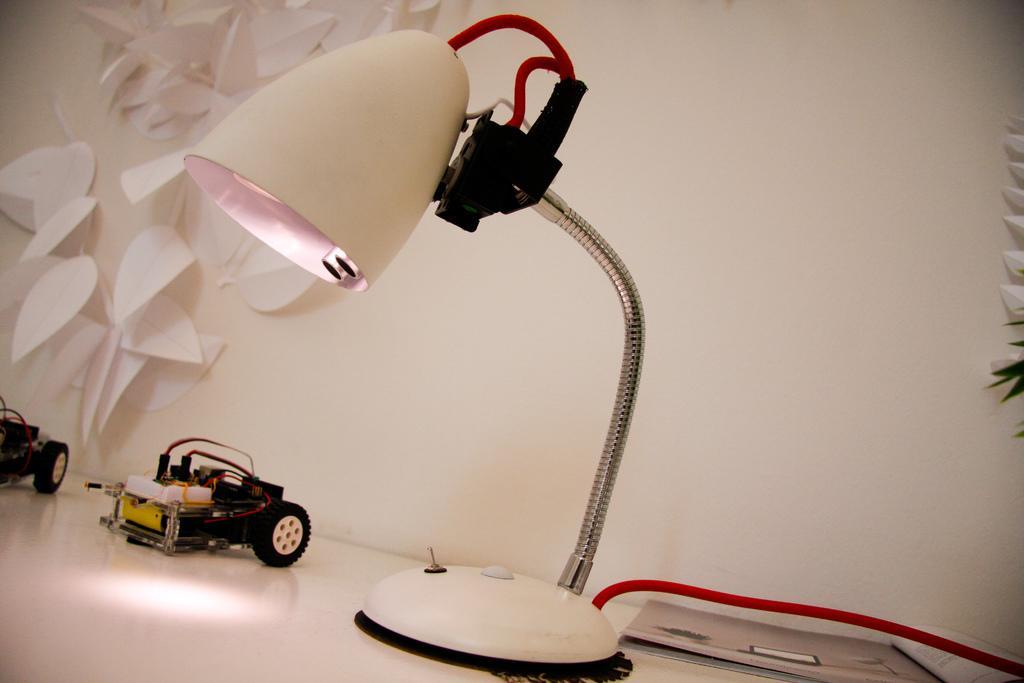Please provide a concise description of this image. In this picture there is white table lamp placed on the table top. Beside there is a small car toys. In the background we can see a white wall with paper stickers. 